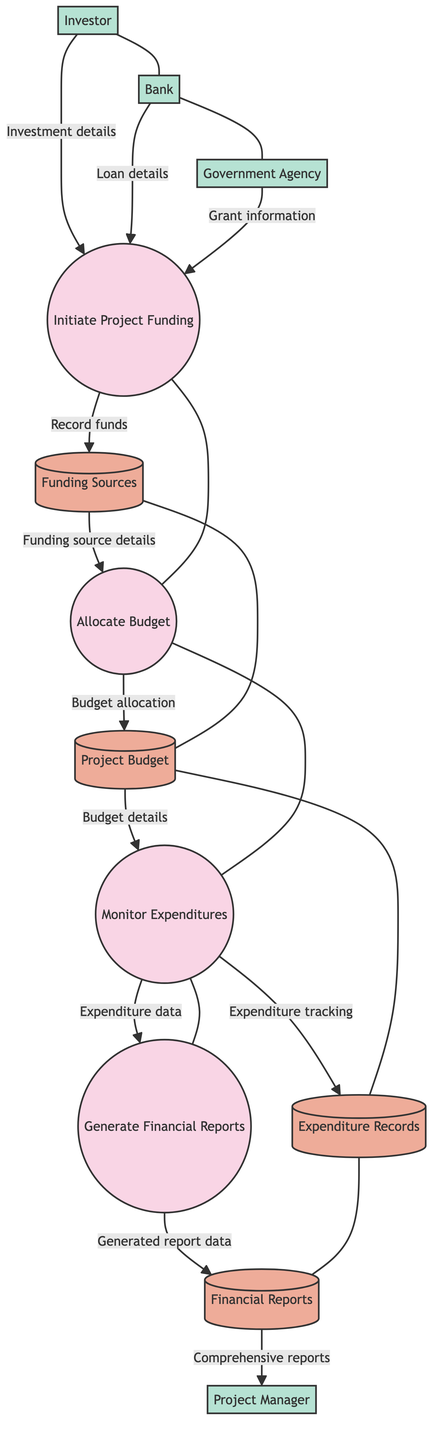What are the external entities involved in the funding process? The external entities are Investor, Bank, Government Agency, and Project Manager, as seen in the diagram where they provide inputs to the process of initiating project funding.
Answer: Investor, Bank, Government Agency, Project Manager How many processes are depicted in the diagram? The diagram includes four processes: Initiate Project Funding, Allocate Budget, Monitor Expenditures, and Generate Financial Reports. Counting these processes yields a total of four.
Answer: Four What type of information does the Funding Sources data store contain? The Funding Sources data store contains information about various funding sources including banks, investors, and grants that contribute to the project funding.
Answer: Information about various funding sources Which process generates financial reports? The process that generates financial reports is labeled as "Generate Financial Reports" and it receives data from the "Monitor Expenditures" process.
Answer: Generate Financial Reports In what order do the processes occur? The processes occur in the following order: Initiate Project Funding, Allocate Budget, Monitor Expenditures, and Generate Financial Reports. This sequence can be traced from one process connecting to the next in the diagram.
Answer: Initiate Project Funding, Allocate Budget, Monitor Expenditures, Generate Financial Reports What data flows from the Project Budget to the Monitor Expenditures? The data flowing from the Project Budget to the Monitor Expenditures is labeled as "Budget details for expenditure monitoring," indicating that budget information is necessary to track expenditures.
Answer: Budget details for expenditure monitoring How does the Project Manager receive financial reports? The Project Manager receives financial reports from the Financial Reports data store after the Generate Financial Reports process completes. This flow is illustrated in the diagram where Financial Reports is directed to the Project Manager.
Answer: From the Financial Reports data store What is recorded in the Expenditure Records data store? The Expenditure Records data store contains expenditure tracking details, which are created during the Monitor Expenditures process, as shown in the flowchart.
Answer: Expenditure tracking details 